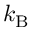Convert formula to latex. <formula><loc_0><loc_0><loc_500><loc_500>k _ { B }</formula> 